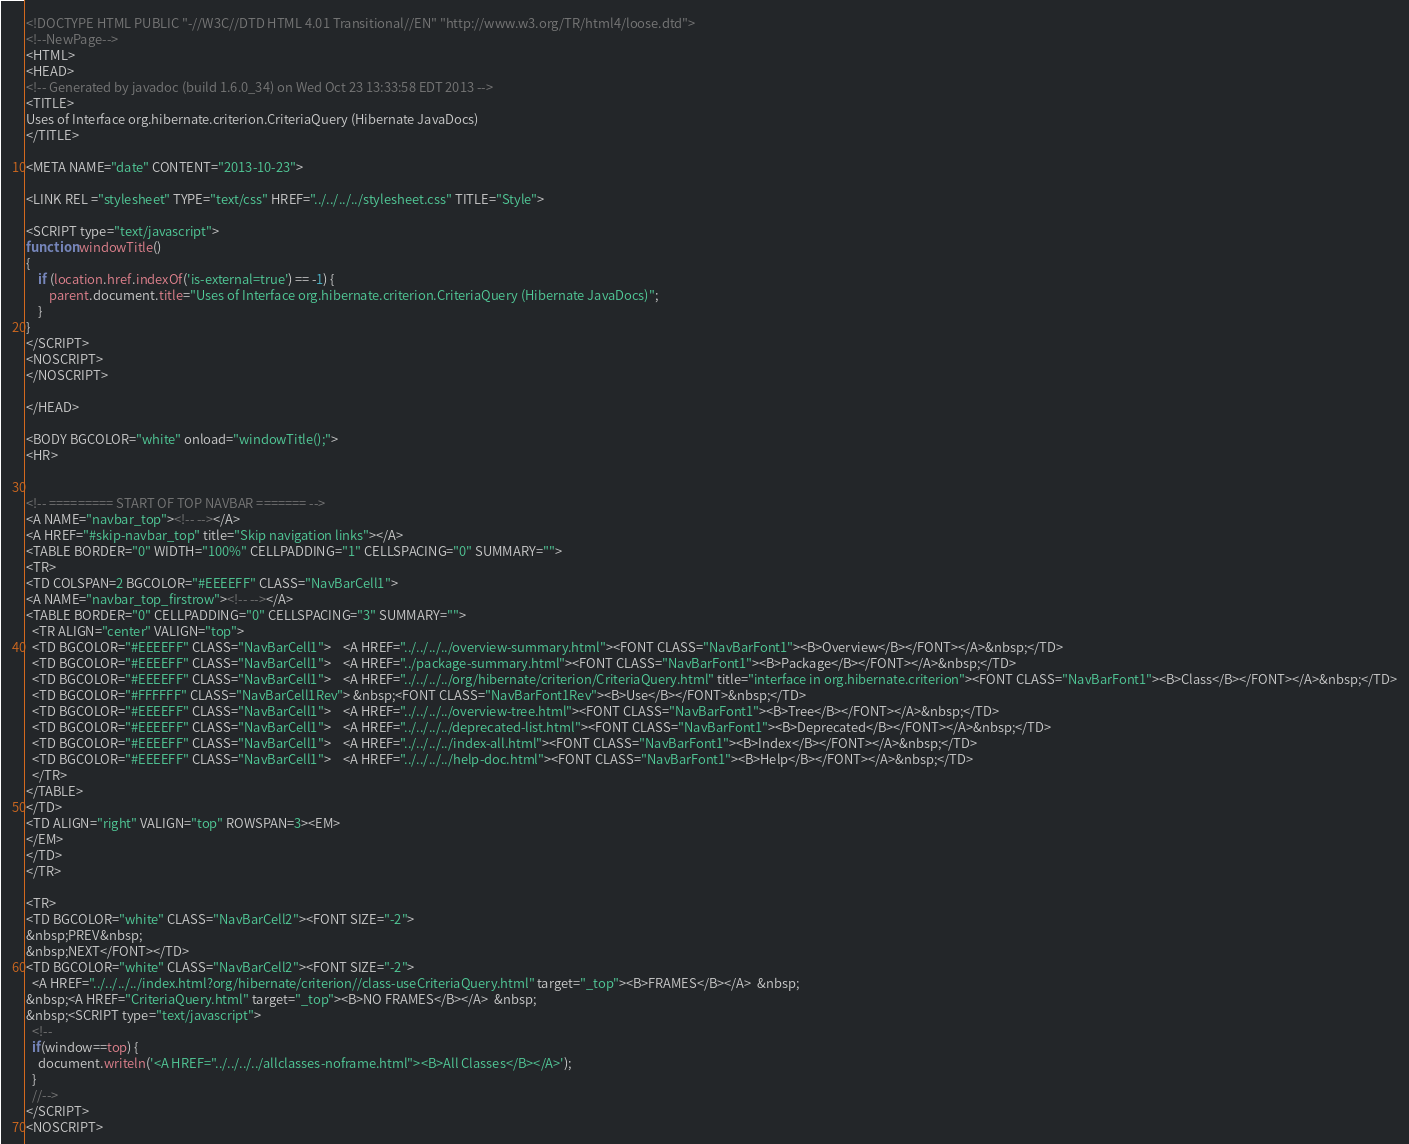<code> <loc_0><loc_0><loc_500><loc_500><_HTML_><!DOCTYPE HTML PUBLIC "-//W3C//DTD HTML 4.01 Transitional//EN" "http://www.w3.org/TR/html4/loose.dtd">
<!--NewPage-->
<HTML>
<HEAD>
<!-- Generated by javadoc (build 1.6.0_34) on Wed Oct 23 13:33:58 EDT 2013 -->
<TITLE>
Uses of Interface org.hibernate.criterion.CriteriaQuery (Hibernate JavaDocs)
</TITLE>

<META NAME="date" CONTENT="2013-10-23">

<LINK REL ="stylesheet" TYPE="text/css" HREF="../../../../stylesheet.css" TITLE="Style">

<SCRIPT type="text/javascript">
function windowTitle()
{
    if (location.href.indexOf('is-external=true') == -1) {
        parent.document.title="Uses of Interface org.hibernate.criterion.CriteriaQuery (Hibernate JavaDocs)";
    }
}
</SCRIPT>
<NOSCRIPT>
</NOSCRIPT>

</HEAD>

<BODY BGCOLOR="white" onload="windowTitle();">
<HR>


<!-- ========= START OF TOP NAVBAR ======= -->
<A NAME="navbar_top"><!-- --></A>
<A HREF="#skip-navbar_top" title="Skip navigation links"></A>
<TABLE BORDER="0" WIDTH="100%" CELLPADDING="1" CELLSPACING="0" SUMMARY="">
<TR>
<TD COLSPAN=2 BGCOLOR="#EEEEFF" CLASS="NavBarCell1">
<A NAME="navbar_top_firstrow"><!-- --></A>
<TABLE BORDER="0" CELLPADDING="0" CELLSPACING="3" SUMMARY="">
  <TR ALIGN="center" VALIGN="top">
  <TD BGCOLOR="#EEEEFF" CLASS="NavBarCell1">    <A HREF="../../../../overview-summary.html"><FONT CLASS="NavBarFont1"><B>Overview</B></FONT></A>&nbsp;</TD>
  <TD BGCOLOR="#EEEEFF" CLASS="NavBarCell1">    <A HREF="../package-summary.html"><FONT CLASS="NavBarFont1"><B>Package</B></FONT></A>&nbsp;</TD>
  <TD BGCOLOR="#EEEEFF" CLASS="NavBarCell1">    <A HREF="../../../../org/hibernate/criterion/CriteriaQuery.html" title="interface in org.hibernate.criterion"><FONT CLASS="NavBarFont1"><B>Class</B></FONT></A>&nbsp;</TD>
  <TD BGCOLOR="#FFFFFF" CLASS="NavBarCell1Rev"> &nbsp;<FONT CLASS="NavBarFont1Rev"><B>Use</B></FONT>&nbsp;</TD>
  <TD BGCOLOR="#EEEEFF" CLASS="NavBarCell1">    <A HREF="../../../../overview-tree.html"><FONT CLASS="NavBarFont1"><B>Tree</B></FONT></A>&nbsp;</TD>
  <TD BGCOLOR="#EEEEFF" CLASS="NavBarCell1">    <A HREF="../../../../deprecated-list.html"><FONT CLASS="NavBarFont1"><B>Deprecated</B></FONT></A>&nbsp;</TD>
  <TD BGCOLOR="#EEEEFF" CLASS="NavBarCell1">    <A HREF="../../../../index-all.html"><FONT CLASS="NavBarFont1"><B>Index</B></FONT></A>&nbsp;</TD>
  <TD BGCOLOR="#EEEEFF" CLASS="NavBarCell1">    <A HREF="../../../../help-doc.html"><FONT CLASS="NavBarFont1"><B>Help</B></FONT></A>&nbsp;</TD>
  </TR>
</TABLE>
</TD>
<TD ALIGN="right" VALIGN="top" ROWSPAN=3><EM>
</EM>
</TD>
</TR>

<TR>
<TD BGCOLOR="white" CLASS="NavBarCell2"><FONT SIZE="-2">
&nbsp;PREV&nbsp;
&nbsp;NEXT</FONT></TD>
<TD BGCOLOR="white" CLASS="NavBarCell2"><FONT SIZE="-2">
  <A HREF="../../../../index.html?org/hibernate/criterion//class-useCriteriaQuery.html" target="_top"><B>FRAMES</B></A>  &nbsp;
&nbsp;<A HREF="CriteriaQuery.html" target="_top"><B>NO FRAMES</B></A>  &nbsp;
&nbsp;<SCRIPT type="text/javascript">
  <!--
  if(window==top) {
    document.writeln('<A HREF="../../../../allclasses-noframe.html"><B>All Classes</B></A>');
  }
  //-->
</SCRIPT>
<NOSCRIPT></code> 